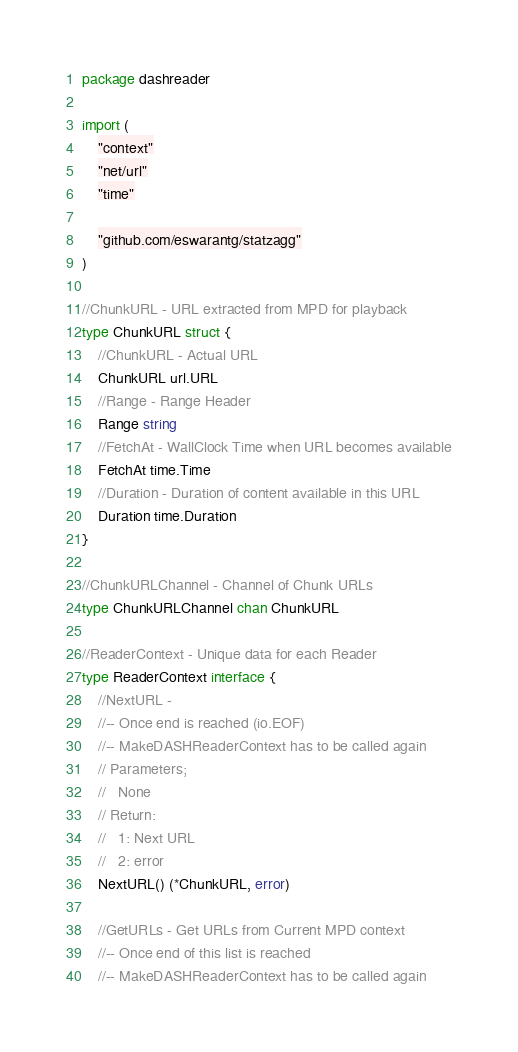<code> <loc_0><loc_0><loc_500><loc_500><_Go_>package dashreader

import (
	"context"
	"net/url"
	"time"

	"github.com/eswarantg/statzagg"
)

//ChunkURL - URL extracted from MPD for playback
type ChunkURL struct {
	//ChunkURL - Actual URL
	ChunkURL url.URL
	//Range - Range Header
	Range string
	//FetchAt - WallClock Time when URL becomes available
	FetchAt time.Time
	//Duration - Duration of content available in this URL
	Duration time.Duration
}

//ChunkURLChannel - Channel of Chunk URLs
type ChunkURLChannel chan ChunkURL

//ReaderContext - Unique data for each Reader
type ReaderContext interface {
	//NextURL -
	//-- Once end is reached (io.EOF)
	//-- MakeDASHReaderContext has to be called again
	// Parameters;
	//   None
	// Return:
	//   1: Next URL
	//   2: error
	NextURL() (*ChunkURL, error)

	//GetURLs - Get URLs from Current MPD context
	//-- Once end of this list is reached
	//-- MakeDASHReaderContext has to be called again</code> 